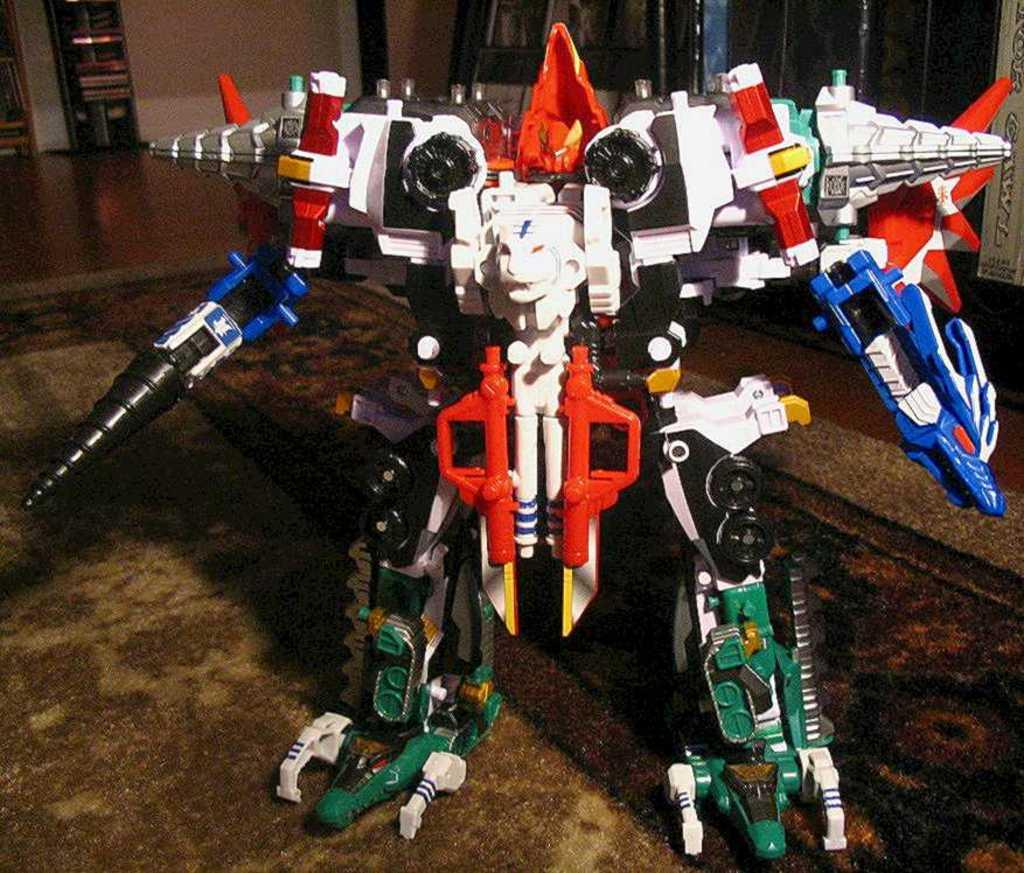Where was the image taken? The image was taken indoors. What can be seen at the bottom of the image? There is a floor visible at the bottom of the image. What is the main subject in the middle of the image? There is a toy robot in the middle of the image. What can be seen in the background of the image? There are walls visible in the background of the image. What type of cactus can be seen in the image? There is no cactus present in the image. How does the toy robot feel about the hot weather in the image? The image does not depict any weather conditions, and the toy robot is an inanimate object, so it cannot feel anything. 